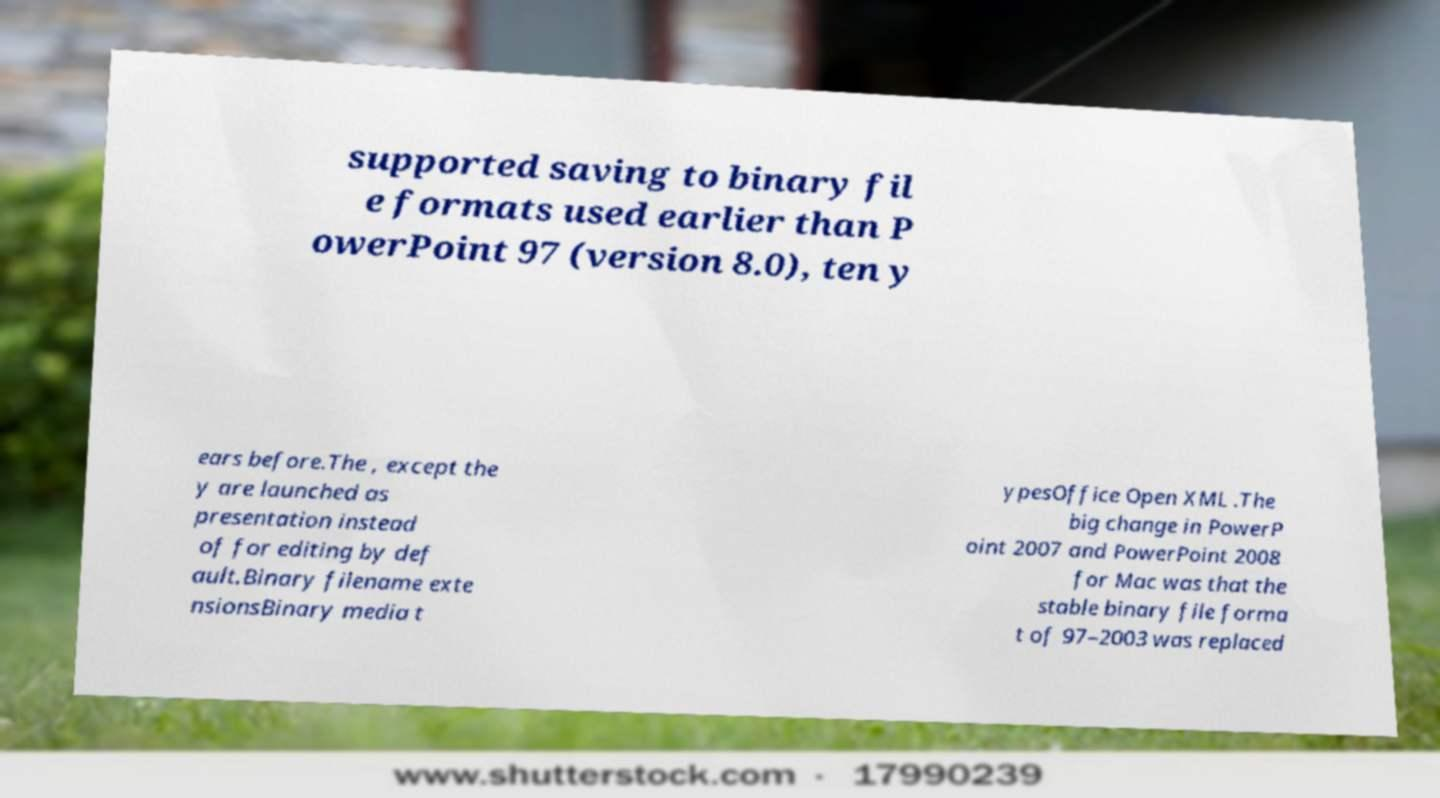Could you extract and type out the text from this image? supported saving to binary fil e formats used earlier than P owerPoint 97 (version 8.0), ten y ears before.The , except the y are launched as presentation instead of for editing by def ault.Binary filename exte nsionsBinary media t ypesOffice Open XML .The big change in PowerP oint 2007 and PowerPoint 2008 for Mac was that the stable binary file forma t of 97–2003 was replaced 